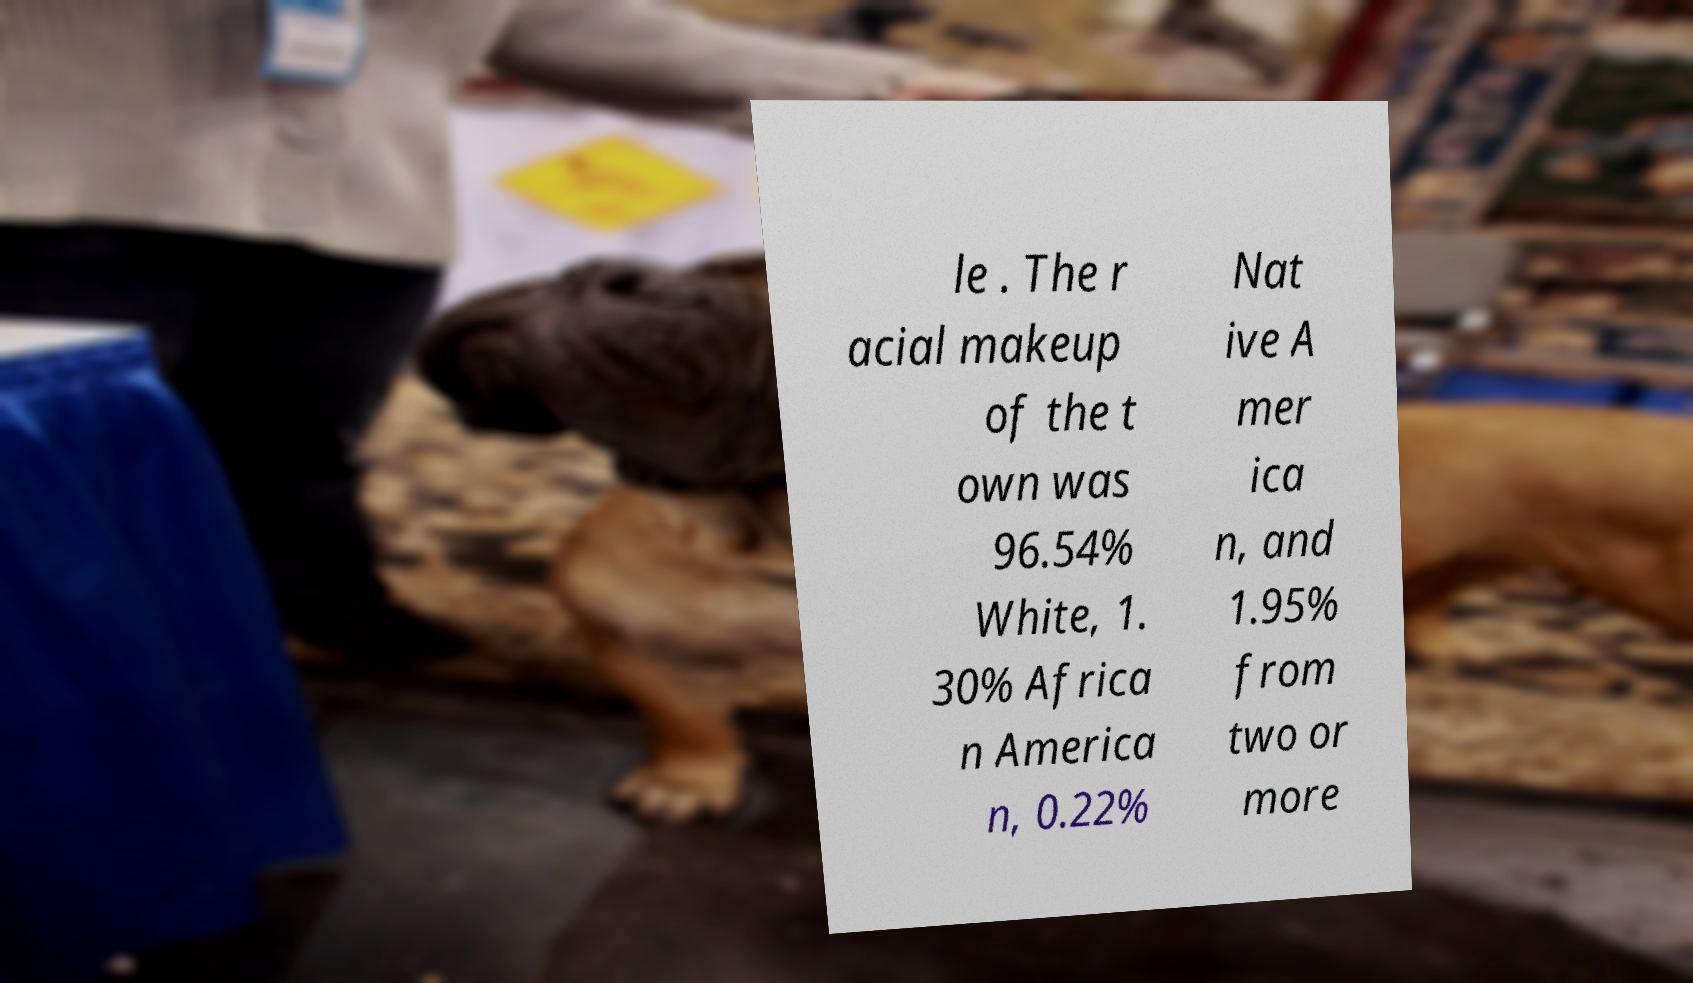Could you extract and type out the text from this image? le . The r acial makeup of the t own was 96.54% White, 1. 30% Africa n America n, 0.22% Nat ive A mer ica n, and 1.95% from two or more 